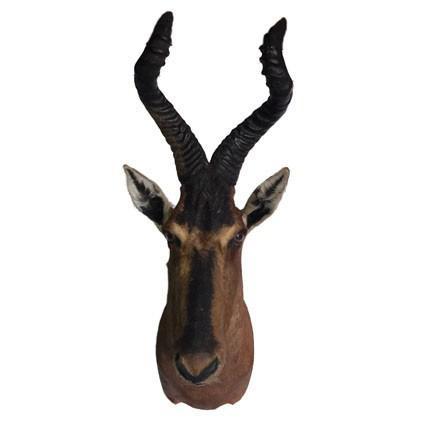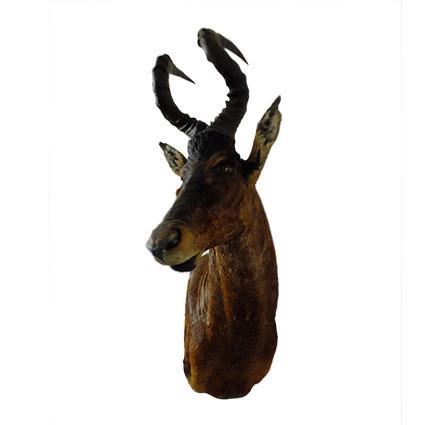The first image is the image on the left, the second image is the image on the right. Assess this claim about the two images: "At least one of the animals is mounted on a grey marblized wall.". Correct or not? Answer yes or no. No. The first image is the image on the left, the second image is the image on the right. Assess this claim about the two images: "The taxidermied horned head on the left faces head-on, and the one on the right is angled leftward.". Correct or not? Answer yes or no. Yes. 